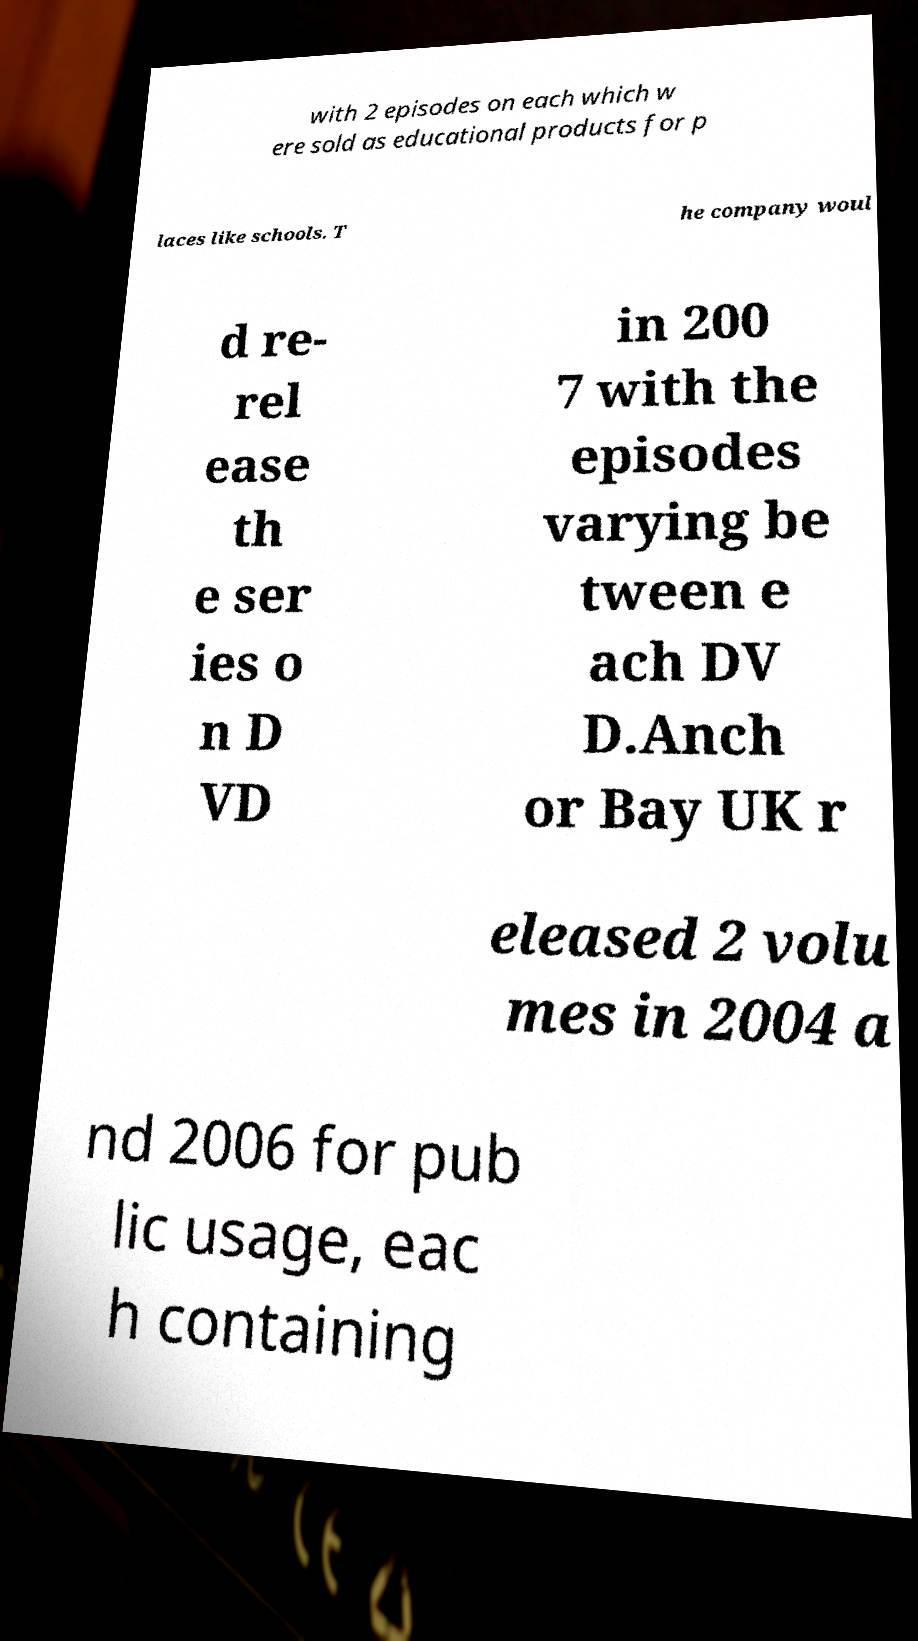What messages or text are displayed in this image? I need them in a readable, typed format. with 2 episodes on each which w ere sold as educational products for p laces like schools. T he company woul d re- rel ease th e ser ies o n D VD in 200 7 with the episodes varying be tween e ach DV D.Anch or Bay UK r eleased 2 volu mes in 2004 a nd 2006 for pub lic usage, eac h containing 